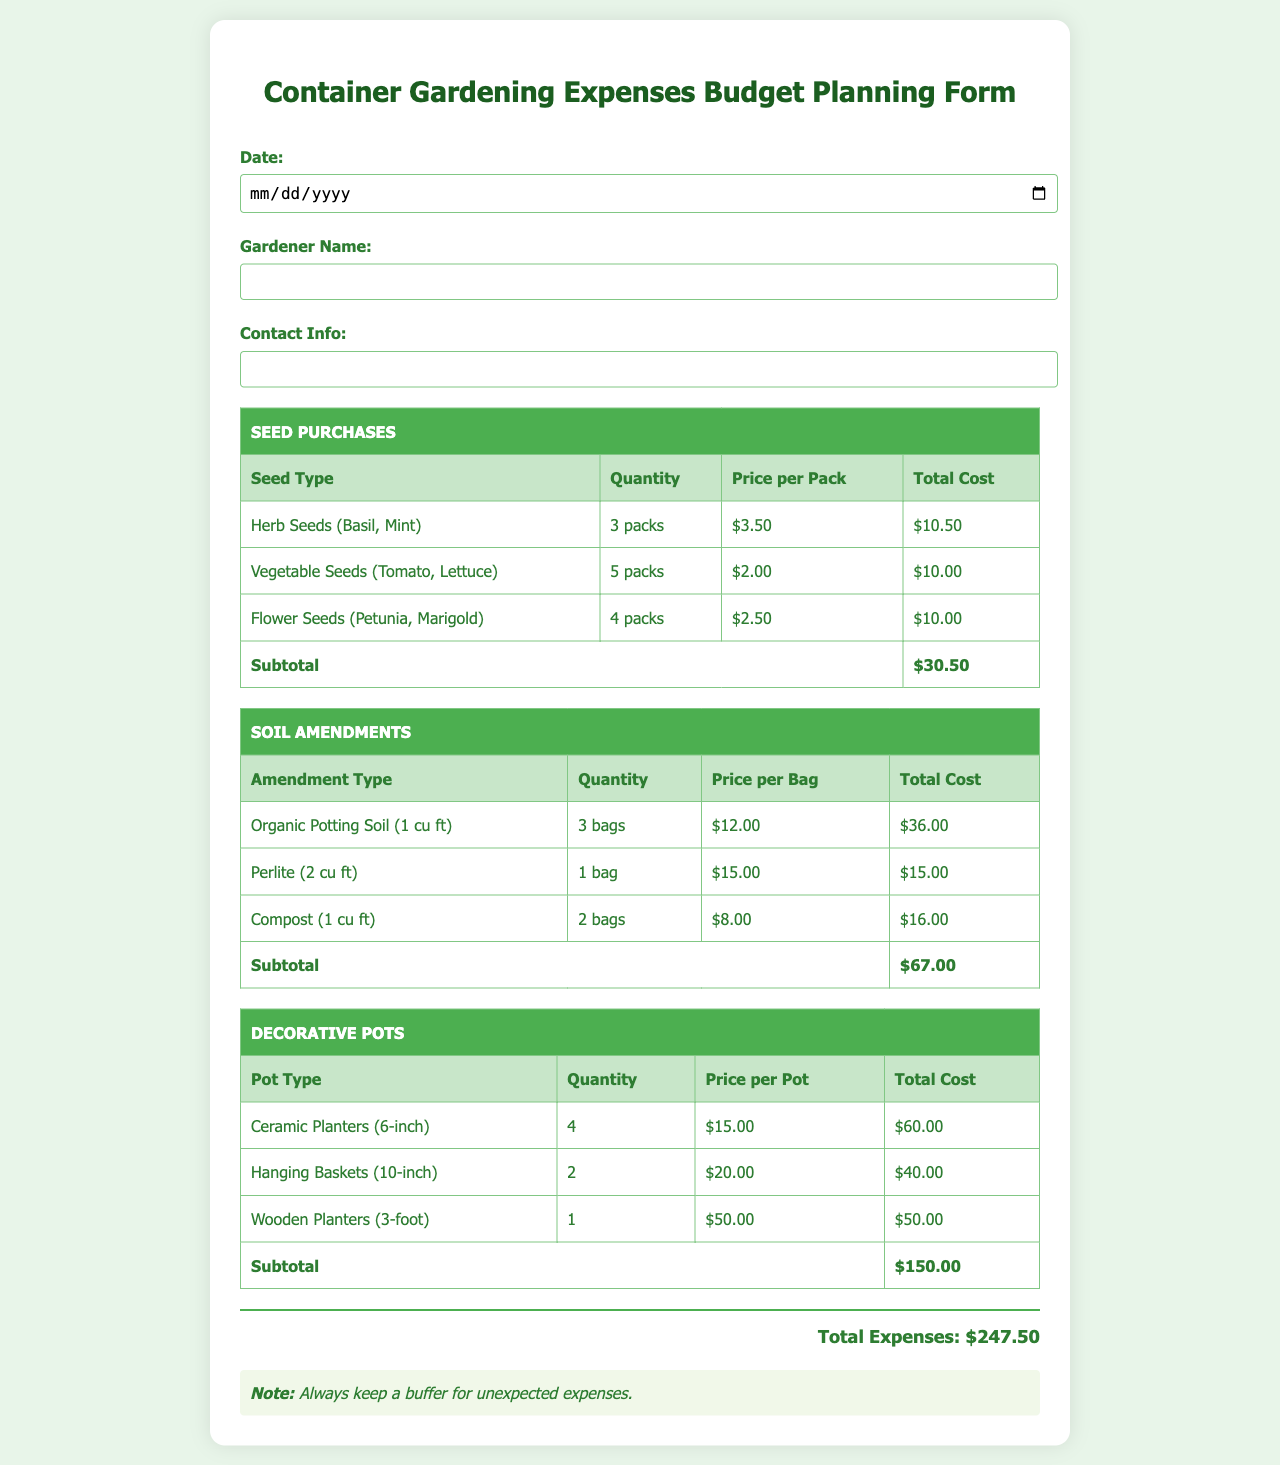What is the total cost for seed purchases? The total cost for seed purchases is obtained from the subtotal in the seed purchases table, which is $30.50.
Answer: $30.50 How many bags of organic potting soil did the gardener buy? The gardener bought 3 bags of organic potting soil as listed in the soil amendments section.
Answer: 3 bags What is the price per pack of vegetable seeds? The price per pack of vegetable seeds is $2.00, as shown in the seed purchases table.
Answer: $2.00 What is the total expense for decorative pots? The total expense for decorative pots is the subtotal from the decorative pots table, which is $150.00.
Answer: $150.00 Who is the gardener listed on the form? The gardener's name is recorded in the form and needs to be filled out by the user; it’s not pre-defined in the document.
Answer: (to be filled out) What is the total budget for this container gardening project? The total budget for the project is represented by the total expenses calculated at the end of the document, which is $247.50.
Answer: $247.50 What type of seed is listed with a total cost of $10.00? Flower seeds are mentioned with a total cost of $10.00 in the seed purchases section.
Answer: Flower Seeds How many clay planters are included in the decorative pots section? The count of ceramic planters is noted in the decorative pots section, amounting to 4.
Answer: 4 What type of soil amendment is being referred to with a unit cost of $15.00? Perlite is indicated as the soil amendment with a unit cost of $15.00 in the soil amendments table.
Answer: Perlite 